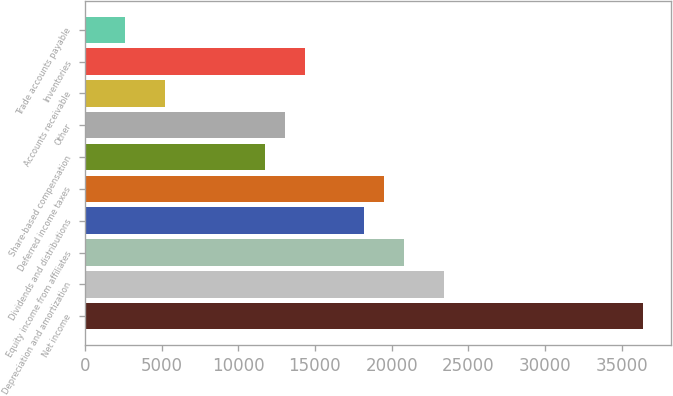Convert chart. <chart><loc_0><loc_0><loc_500><loc_500><bar_chart><fcel>Net income<fcel>Depreciation and amortization<fcel>Equity income from affiliates<fcel>Dividends and distributions<fcel>Deferred income taxes<fcel>Share-based compensation<fcel>Other<fcel>Accounts receivable<fcel>Inventories<fcel>Trade accounts payable<nl><fcel>36416.6<fcel>23419.6<fcel>20820.2<fcel>18220.8<fcel>19520.5<fcel>11722.3<fcel>13022<fcel>5223.8<fcel>14321.7<fcel>2624.4<nl></chart> 